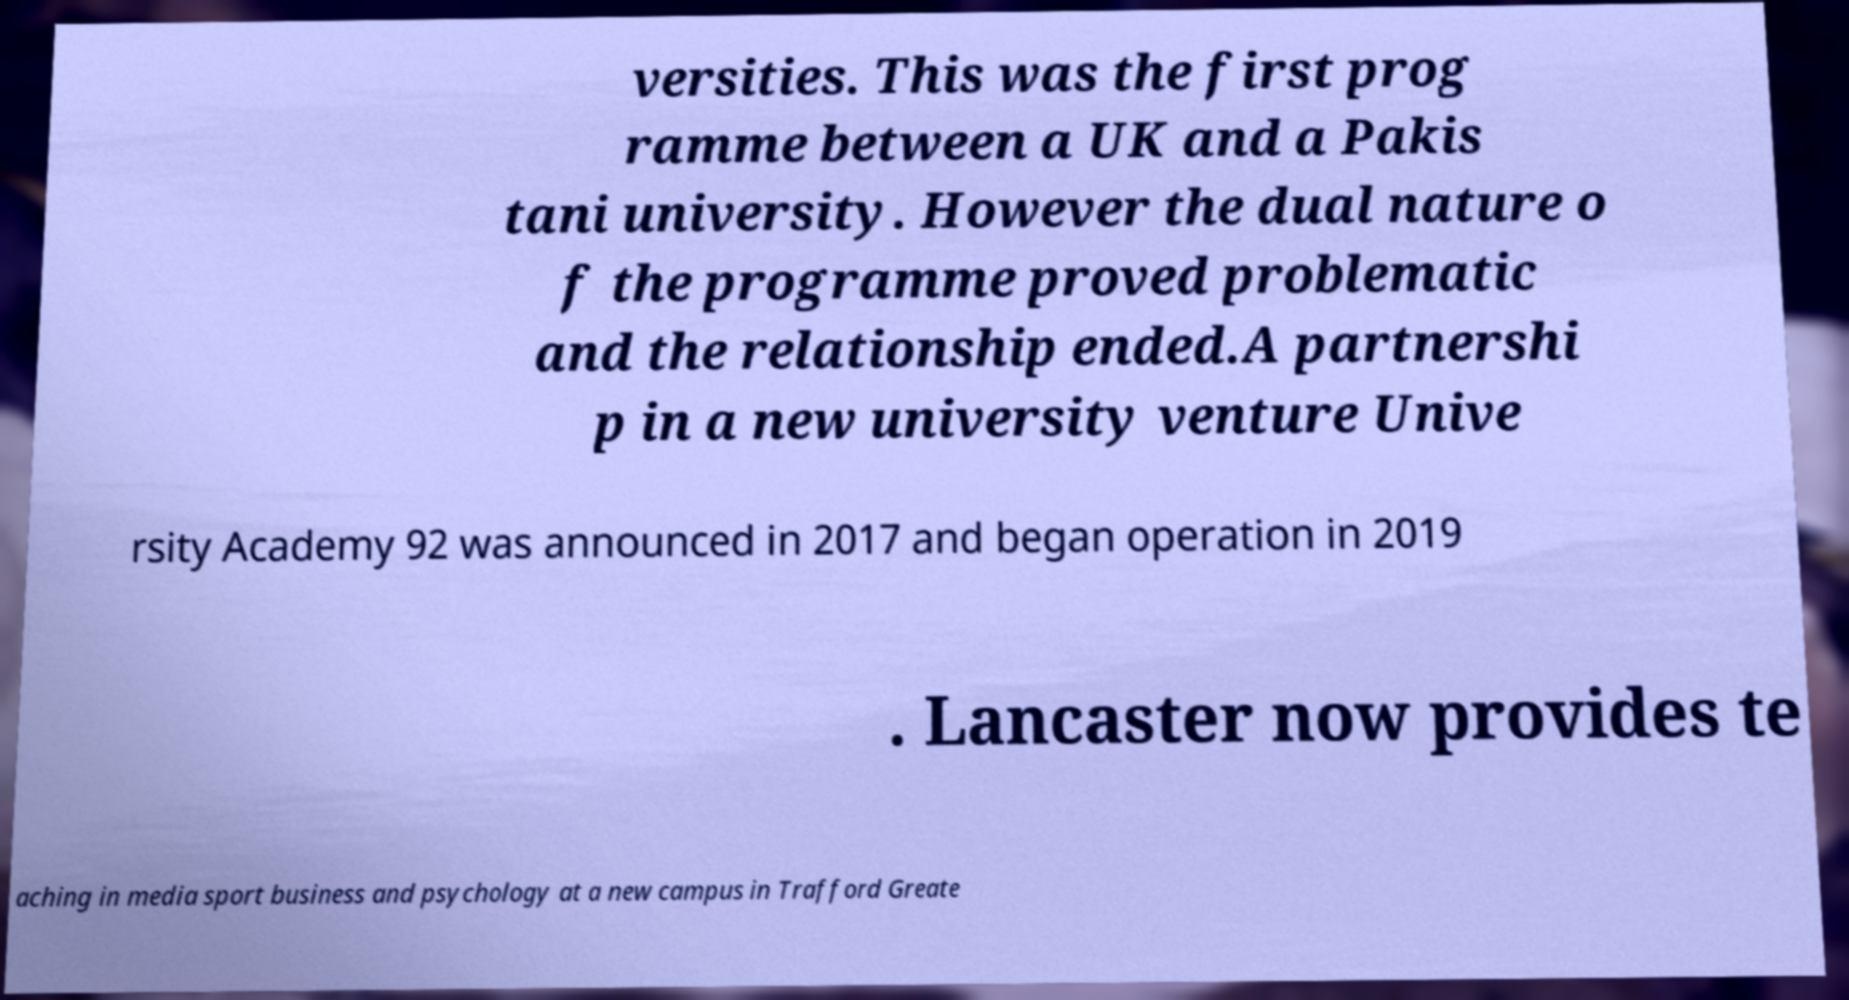I need the written content from this picture converted into text. Can you do that? versities. This was the first prog ramme between a UK and a Pakis tani university. However the dual nature o f the programme proved problematic and the relationship ended.A partnershi p in a new university venture Unive rsity Academy 92 was announced in 2017 and began operation in 2019 . Lancaster now provides te aching in media sport business and psychology at a new campus in Trafford Greate 